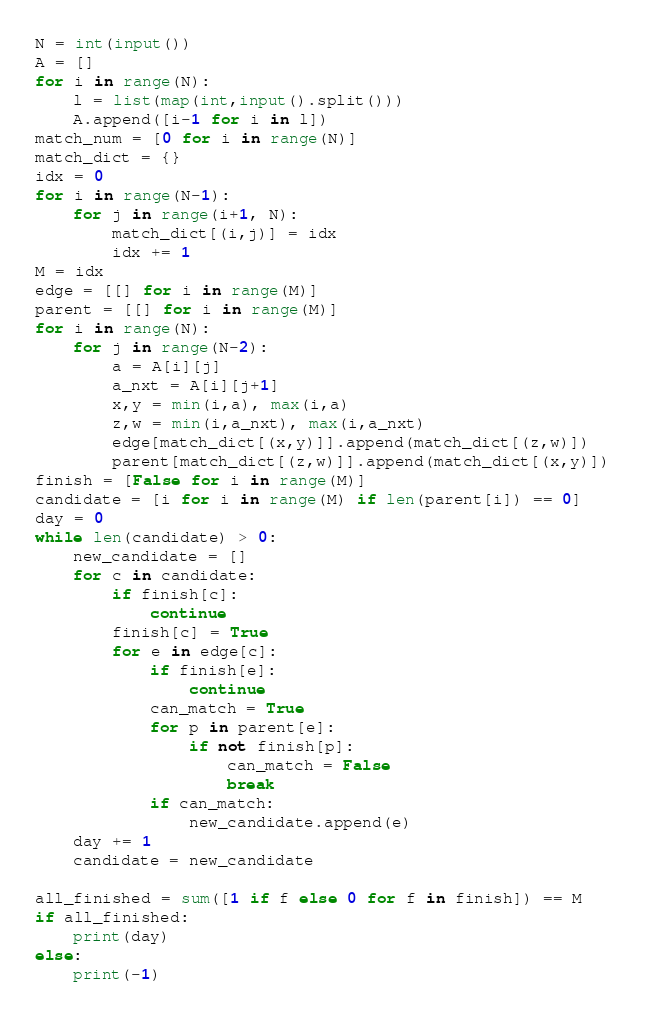Convert code to text. <code><loc_0><loc_0><loc_500><loc_500><_Python_>N = int(input())
A = []
for i in range(N):
	l = list(map(int,input().split()))
	A.append([i-1 for i in l])
match_num = [0 for i in range(N)]
match_dict = {}
idx = 0
for i in range(N-1):
	for j in range(i+1, N):
		match_dict[(i,j)] = idx
		idx += 1
M = idx
edge = [[] for i in range(M)]
parent = [[] for i in range(M)]
for i in range(N):
	for j in range(N-2):
		a = A[i][j]
		a_nxt = A[i][j+1]
		x,y = min(i,a), max(i,a)
		z,w = min(i,a_nxt), max(i,a_nxt)
		edge[match_dict[(x,y)]].append(match_dict[(z,w)])
		parent[match_dict[(z,w)]].append(match_dict[(x,y)])
finish = [False for i in range(M)]
candidate = [i for i in range(M) if len(parent[i]) == 0]
day = 0
while len(candidate) > 0:
	new_candidate = []
	for c in candidate:
		if finish[c]:
			continue
		finish[c] = True
		for e in edge[c]:
			if finish[e]:
				continue
			can_match = True
			for p in parent[e]:
				if not finish[p]:
					can_match = False
					break
			if can_match:
				new_candidate.append(e)
	day += 1
	candidate = new_candidate

all_finished = sum([1 if f else 0 for f in finish]) == M
if all_finished:
	print(day)
else:
	print(-1)</code> 